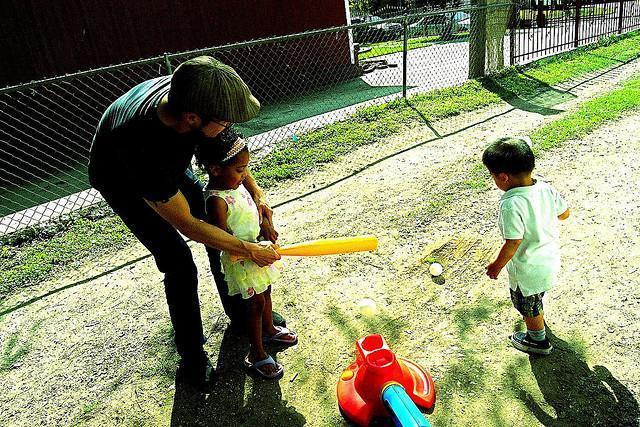How many children are there?
Give a very brief answer. 2. How many people are there?
Give a very brief answer. 3. 